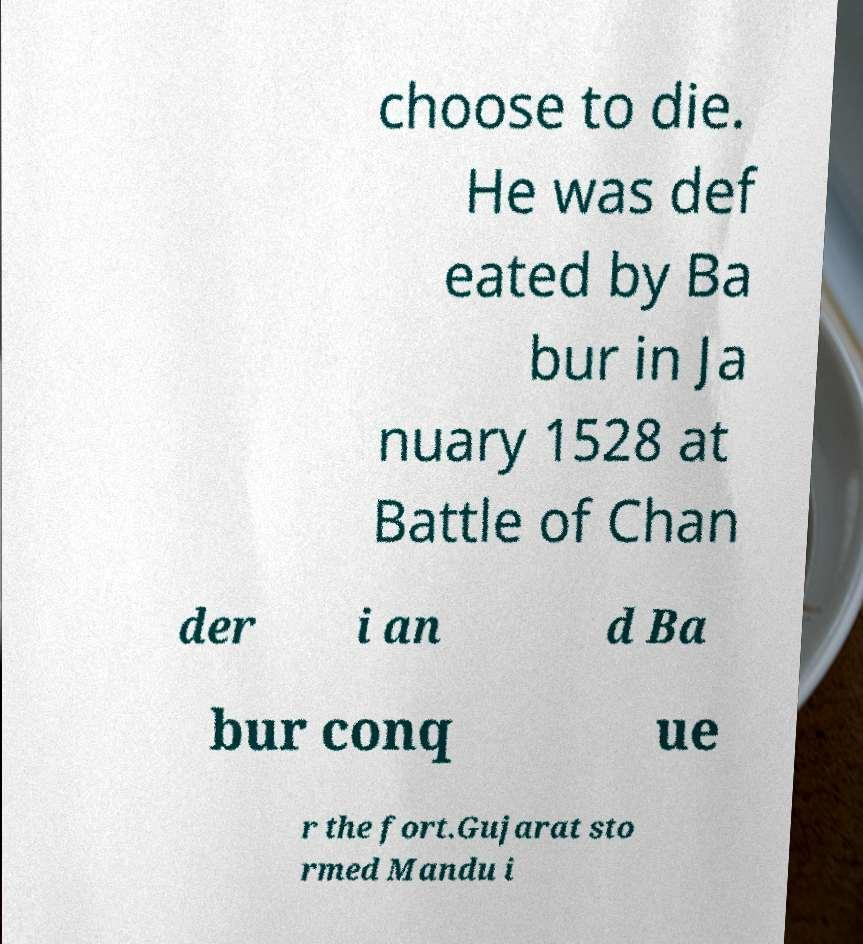There's text embedded in this image that I need extracted. Can you transcribe it verbatim? choose to die. He was def eated by Ba bur in Ja nuary 1528 at Battle of Chan der i an d Ba bur conq ue r the fort.Gujarat sto rmed Mandu i 